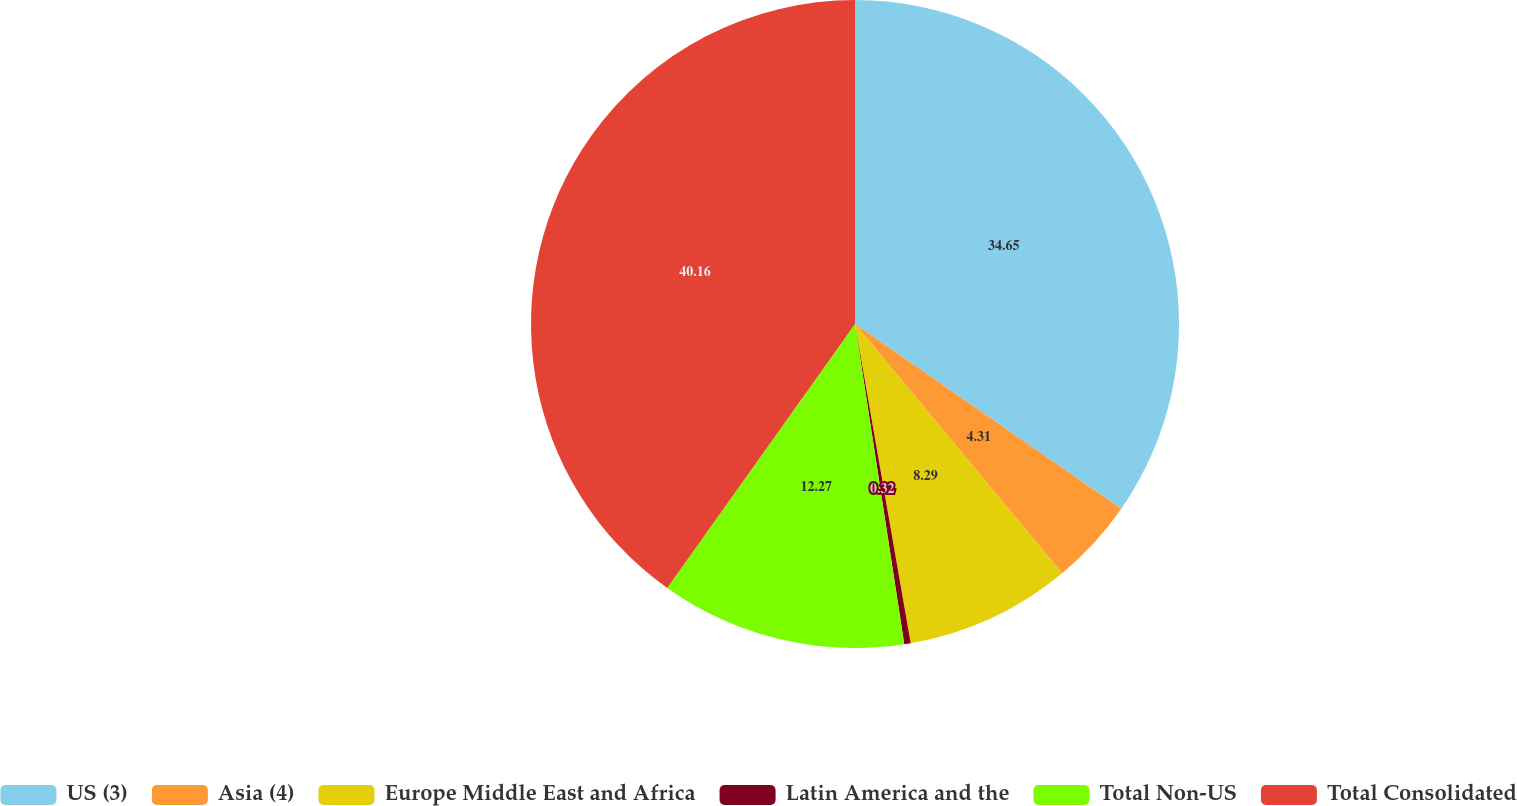Convert chart to OTSL. <chart><loc_0><loc_0><loc_500><loc_500><pie_chart><fcel>US (3)<fcel>Asia (4)<fcel>Europe Middle East and Africa<fcel>Latin America and the<fcel>Total Non-US<fcel>Total Consolidated<nl><fcel>34.65%<fcel>4.31%<fcel>8.29%<fcel>0.32%<fcel>12.27%<fcel>40.16%<nl></chart> 